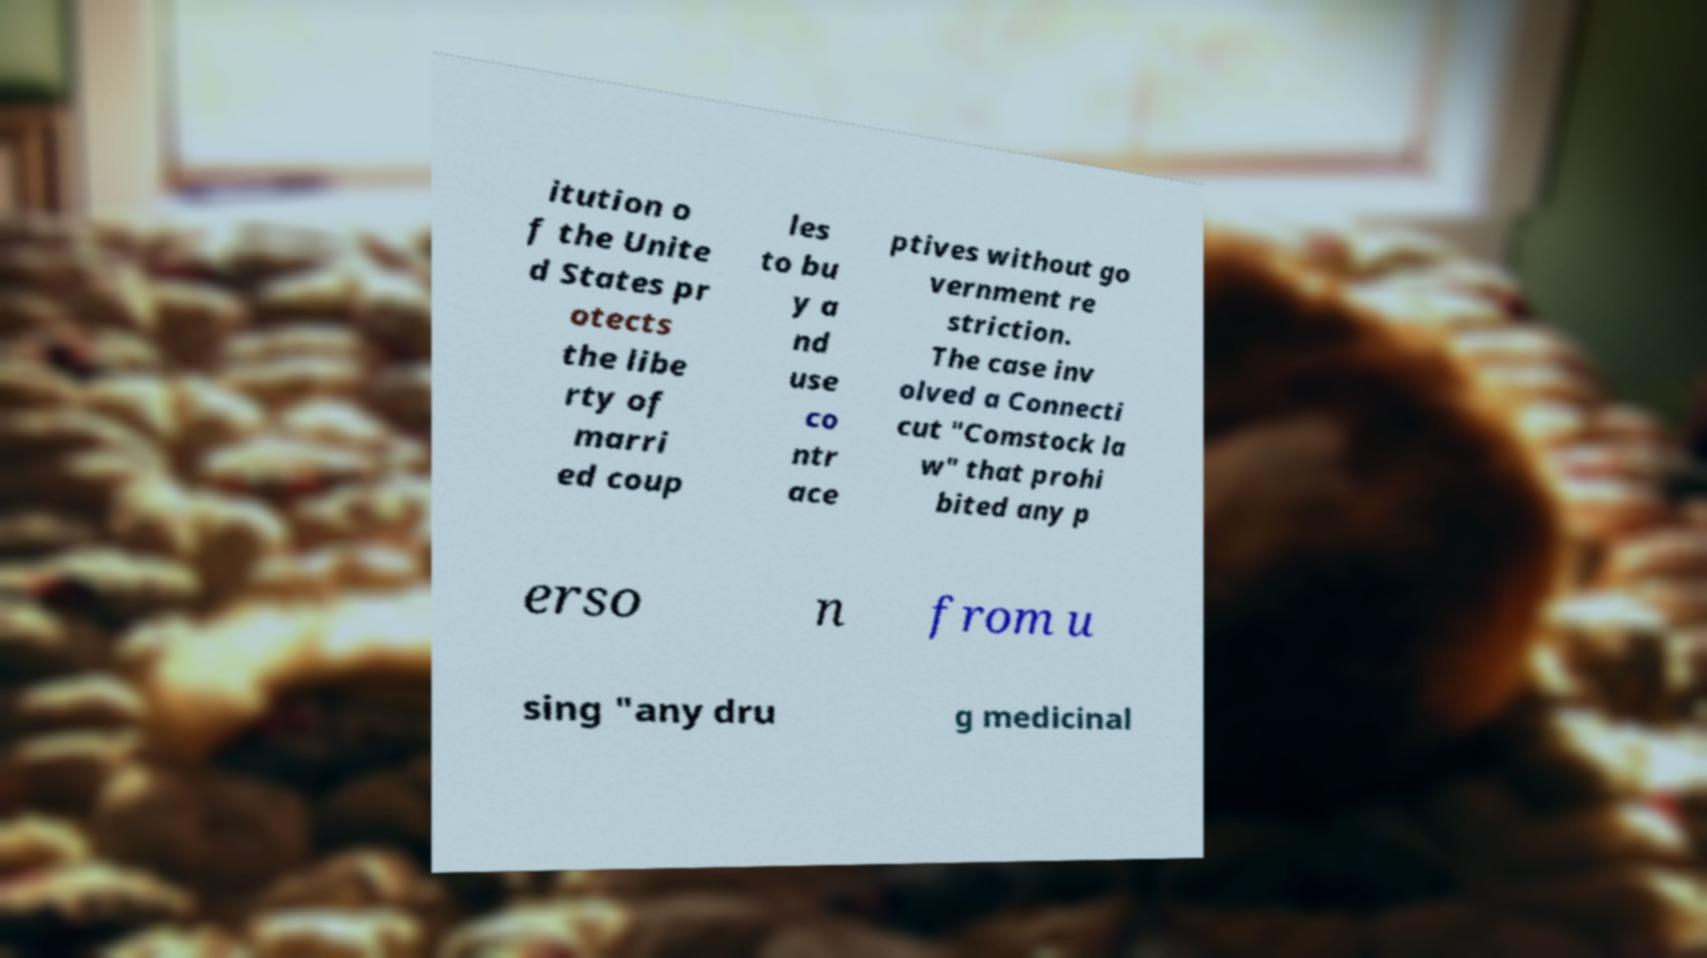I need the written content from this picture converted into text. Can you do that? itution o f the Unite d States pr otects the libe rty of marri ed coup les to bu y a nd use co ntr ace ptives without go vernment re striction. The case inv olved a Connecti cut "Comstock la w" that prohi bited any p erso n from u sing "any dru g medicinal 